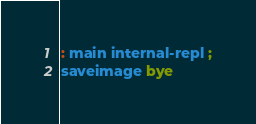<code> <loc_0><loc_0><loc_500><loc_500><_Forth_>: main internal-repl ;
saveimage bye</code> 